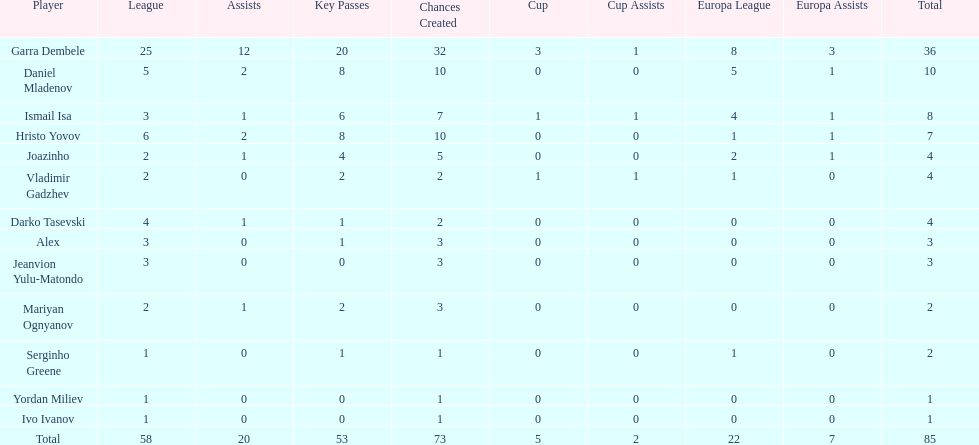Which is the only player from germany? Jeanvion Yulu-Matondo. 